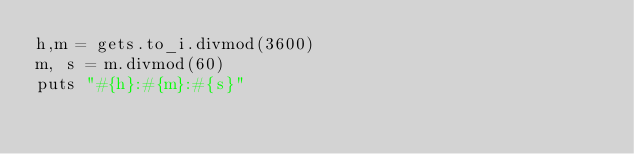Convert code to text. <code><loc_0><loc_0><loc_500><loc_500><_Ruby_>h,m = gets.to_i.divmod(3600)
m, s = m.divmod(60)
puts "#{h}:#{m}:#{s}"</code> 